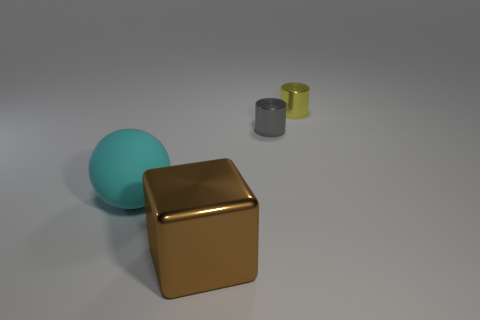There is a small shiny thing on the right side of the tiny gray shiny cylinder; does it have the same shape as the big cyan thing?
Offer a very short reply. No. Is the number of large brown metal objects behind the large cyan thing less than the number of small cylinders that are on the right side of the gray metallic object?
Offer a terse response. Yes. What number of other things are the same shape as the tiny gray metallic thing?
Your answer should be very brief. 1. There is a object that is in front of the large thing left of the big object that is in front of the ball; how big is it?
Keep it short and to the point. Large. What number of brown objects are metal things or big balls?
Provide a short and direct response. 1. There is a metal thing in front of the large thing that is behind the cube; what is its shape?
Give a very brief answer. Cube. Is the size of the metal object that is in front of the big cyan matte ball the same as the thing that is left of the large brown object?
Your answer should be compact. Yes. Is there a cylinder that has the same material as the brown cube?
Give a very brief answer. Yes. There is a object that is in front of the large object that is to the left of the brown shiny block; is there a metal cylinder that is right of it?
Make the answer very short. Yes. Are there any gray metallic cylinders on the right side of the gray metal thing?
Offer a terse response. No. 